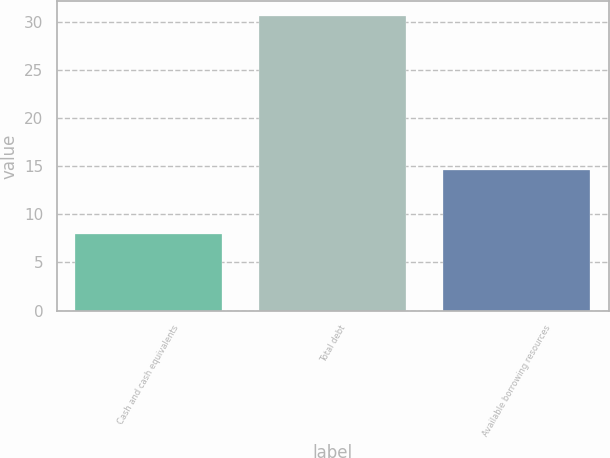<chart> <loc_0><loc_0><loc_500><loc_500><bar_chart><fcel>Cash and cash equivalents<fcel>Total debt<fcel>Available borrowing resources<nl><fcel>8<fcel>30.6<fcel>14.6<nl></chart> 